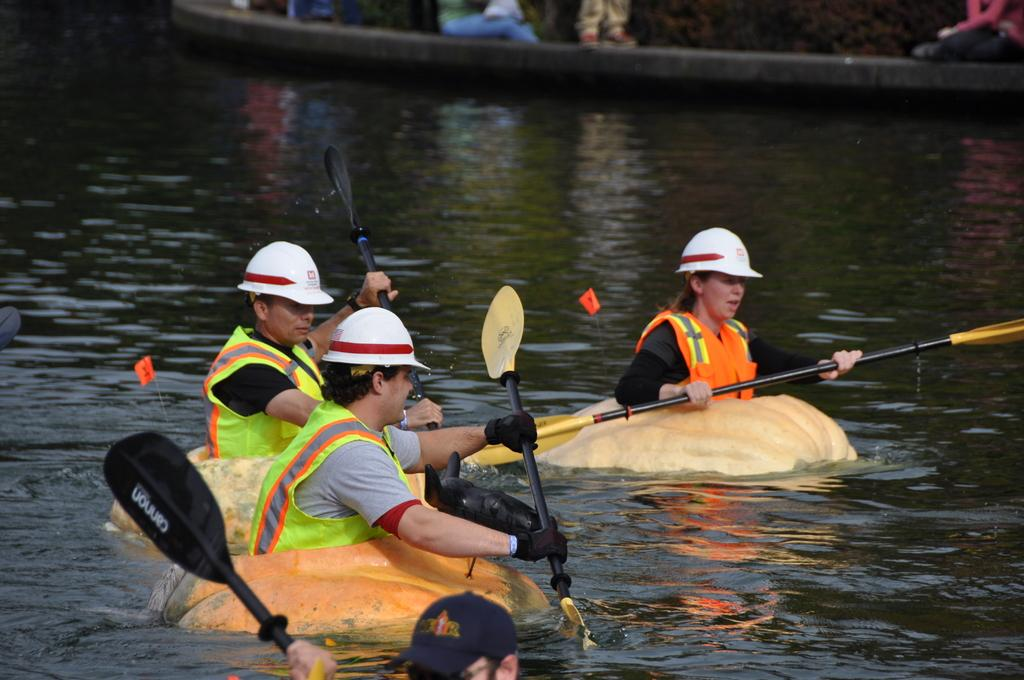How many people are in the image? There are three people in the image. What are the people doing in the image? The people are riding boats on the water. What protective gear are the people wearing? The people are wearing helmets. What objects are the people holding in their hands? The people are holding pebbles. Can you describe the background of the image? There are people visible in the background of the image. What type of servant can be seen attending to the people in the image? There is no servant present in the image; the three people are riding boats on their own. What coastline can be seen in the background of the image? The image does not show a coastline; it features people riding boats on the water. 